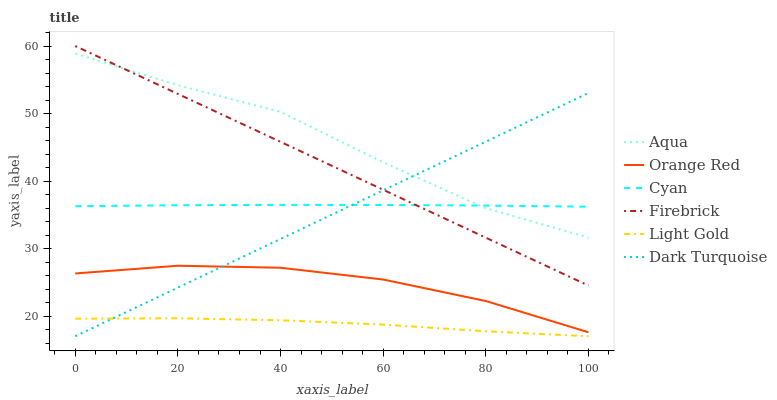Does Light Gold have the minimum area under the curve?
Answer yes or no. Yes. Does Aqua have the maximum area under the curve?
Answer yes or no. Yes. Does Firebrick have the minimum area under the curve?
Answer yes or no. No. Does Firebrick have the maximum area under the curve?
Answer yes or no. No. Is Firebrick the smoothest?
Answer yes or no. Yes. Is Aqua the roughest?
Answer yes or no. Yes. Is Aqua the smoothest?
Answer yes or no. No. Is Firebrick the roughest?
Answer yes or no. No. Does Dark Turquoise have the lowest value?
Answer yes or no. Yes. Does Firebrick have the lowest value?
Answer yes or no. No. Does Firebrick have the highest value?
Answer yes or no. Yes. Does Aqua have the highest value?
Answer yes or no. No. Is Light Gold less than Cyan?
Answer yes or no. Yes. Is Firebrick greater than Orange Red?
Answer yes or no. Yes. Does Light Gold intersect Dark Turquoise?
Answer yes or no. Yes. Is Light Gold less than Dark Turquoise?
Answer yes or no. No. Is Light Gold greater than Dark Turquoise?
Answer yes or no. No. Does Light Gold intersect Cyan?
Answer yes or no. No. 